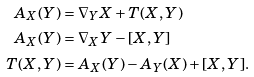Convert formula to latex. <formula><loc_0><loc_0><loc_500><loc_500>A _ { X } ( Y ) & = \nabla _ { Y } X + T ( X , Y ) \\ A _ { X } ( Y ) & = \nabla _ { X } Y - [ X , Y ] \\ T ( X , Y ) & = A _ { X } ( Y ) - A _ { Y } ( X ) + [ X , Y ] .</formula> 